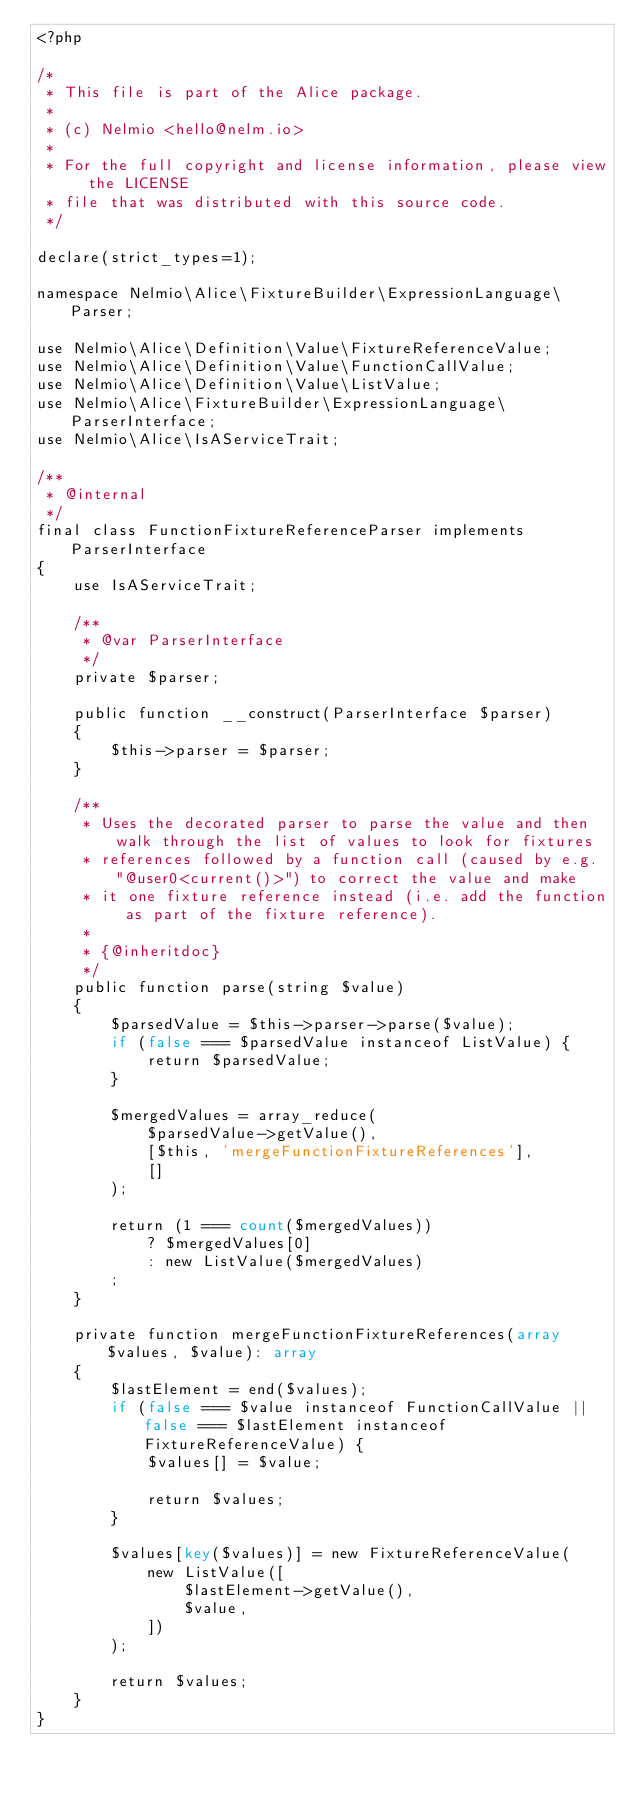Convert code to text. <code><loc_0><loc_0><loc_500><loc_500><_PHP_><?php

/*
 * This file is part of the Alice package.
 *
 * (c) Nelmio <hello@nelm.io>
 *
 * For the full copyright and license information, please view the LICENSE
 * file that was distributed with this source code.
 */

declare(strict_types=1);

namespace Nelmio\Alice\FixtureBuilder\ExpressionLanguage\Parser;

use Nelmio\Alice\Definition\Value\FixtureReferenceValue;
use Nelmio\Alice\Definition\Value\FunctionCallValue;
use Nelmio\Alice\Definition\Value\ListValue;
use Nelmio\Alice\FixtureBuilder\ExpressionLanguage\ParserInterface;
use Nelmio\Alice\IsAServiceTrait;

/**
 * @internal
 */
final class FunctionFixtureReferenceParser implements ParserInterface
{
    use IsAServiceTrait;

    /**
     * @var ParserInterface
     */
    private $parser;

    public function __construct(ParserInterface $parser)
    {
        $this->parser = $parser;
    }

    /**
     * Uses the decorated parser to parse the value and then walk through the list of values to look for fixtures
     * references followed by a function call (caused by e.g. "@user0<current()>") to correct the value and make
     * it one fixture reference instead (i.e. add the function as part of the fixture reference).
     *
     * {@inheritdoc}
     */
    public function parse(string $value)
    {
        $parsedValue = $this->parser->parse($value);
        if (false === $parsedValue instanceof ListValue) {
            return $parsedValue;
        }

        $mergedValues = array_reduce(
            $parsedValue->getValue(),
            [$this, 'mergeFunctionFixtureReferences'],
            []
        );

        return (1 === count($mergedValues))
            ? $mergedValues[0]
            : new ListValue($mergedValues)
        ;
    }
    
    private function mergeFunctionFixtureReferences(array $values, $value): array
    {
        $lastElement = end($values);
        if (false === $value instanceof FunctionCallValue || false === $lastElement instanceof FixtureReferenceValue) {
            $values[] = $value;

            return $values;
        }

        $values[key($values)] = new FixtureReferenceValue(
            new ListValue([
                $lastElement->getValue(),
                $value,
            ])
        );

        return $values;
    }
}
</code> 